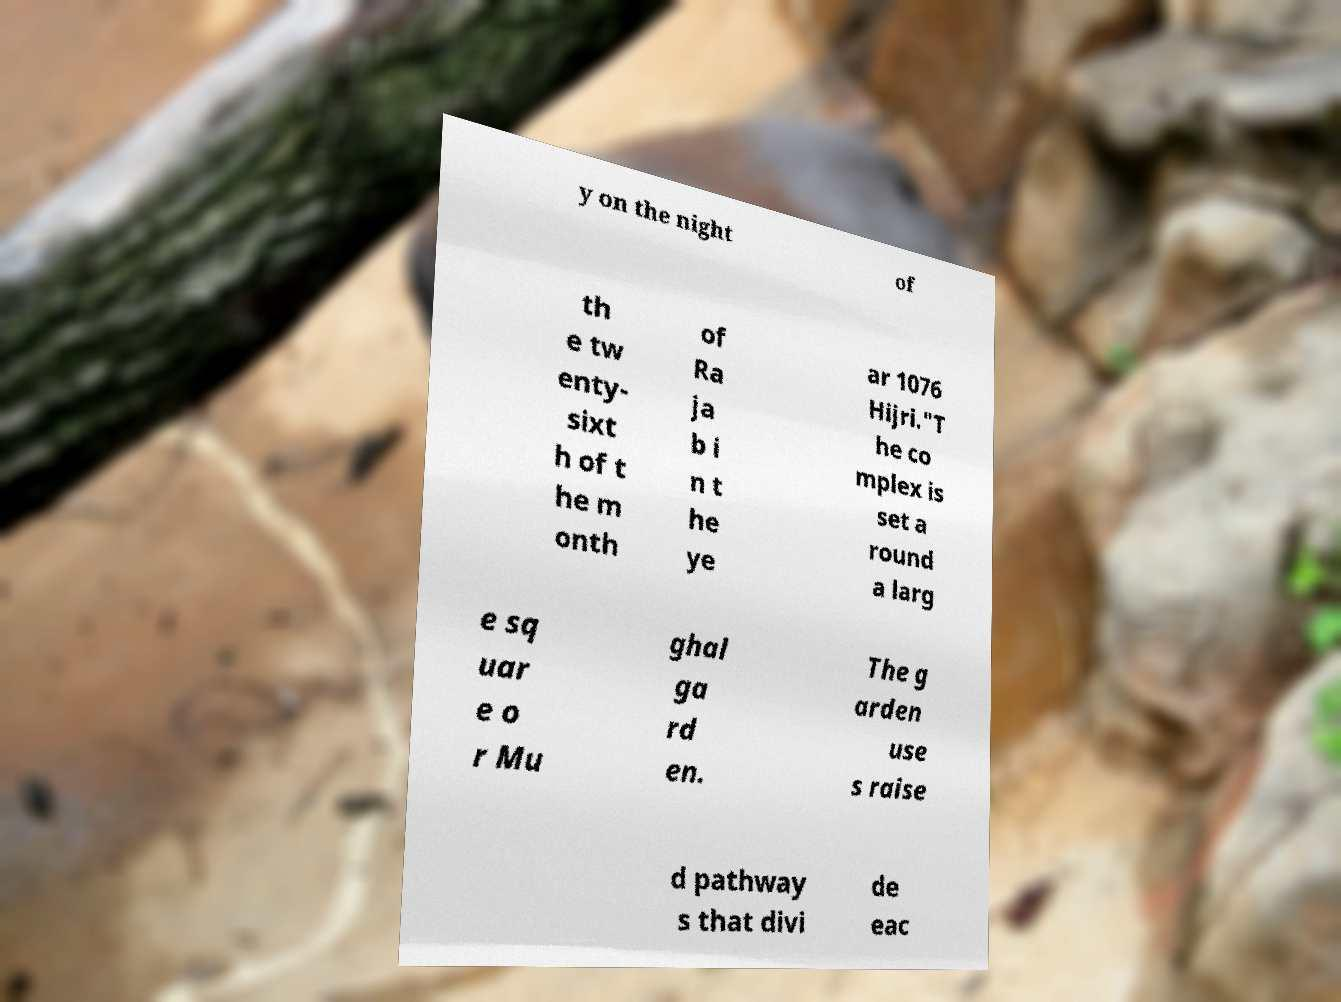Please read and relay the text visible in this image. What does it say? y on the night of th e tw enty- sixt h of t he m onth of Ra ja b i n t he ye ar 1076 Hijri."T he co mplex is set a round a larg e sq uar e o r Mu ghal ga rd en. The g arden use s raise d pathway s that divi de eac 